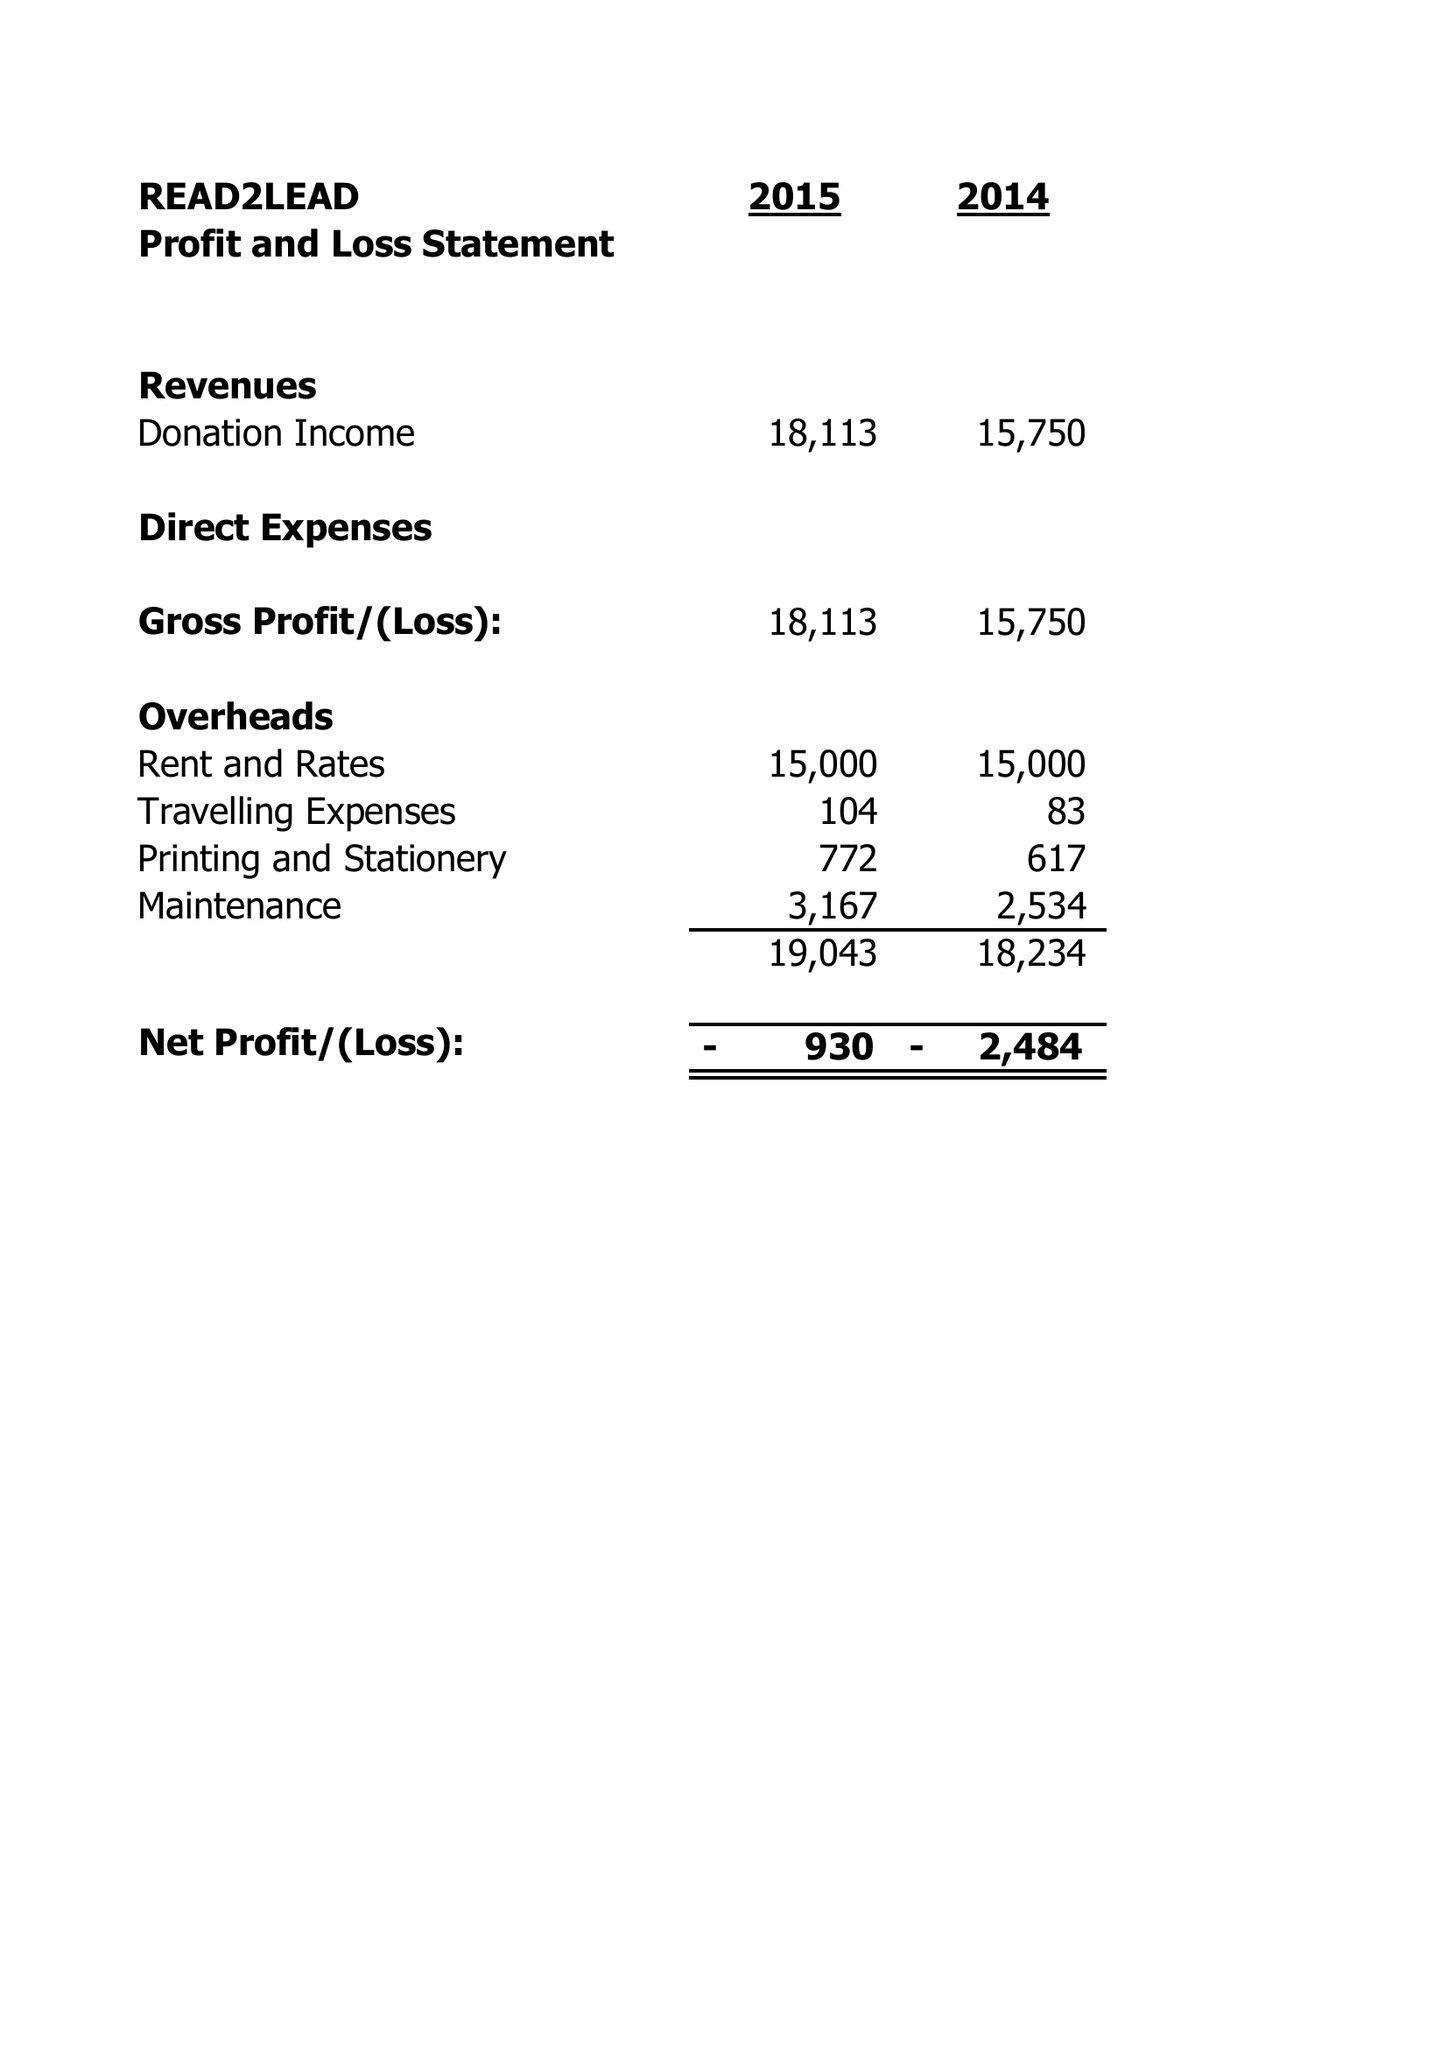What is the value for the address__postcode?
Answer the question using a single word or phrase. B8 1RS 